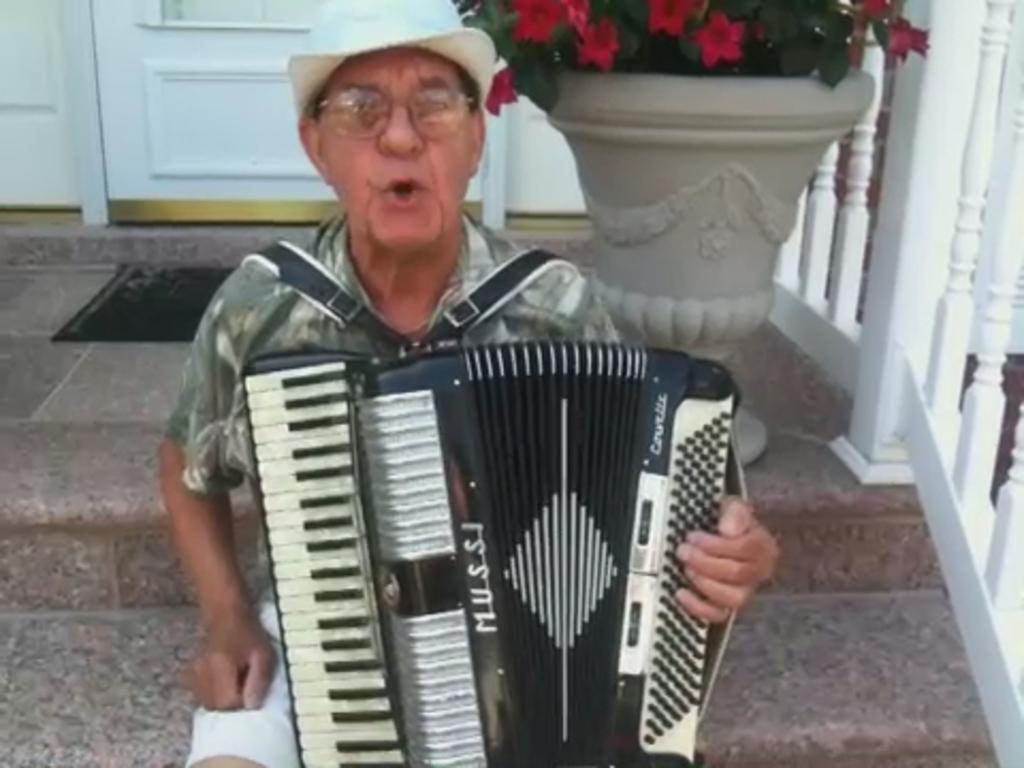What is the man in the image doing? The man is sitting in the image. What is the man wearing? The man is wearing clothes, spectacles, and a hat. What is the man holding or interacting with in the image? The man has a musical instrument on his lap. What other objects or structures can be seen in the image? There is a flower pot, a fence, stairs, and a door in the image. How does the man feel about the dust in the image? There is no mention of dust in the image, so it is not possible to determine how the man feels about it. 